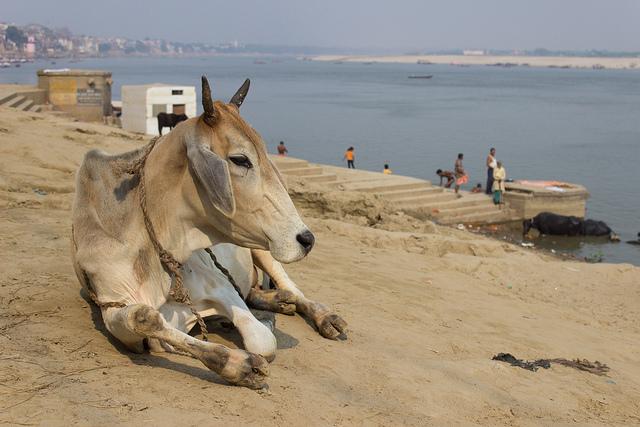Is this a farm?
Quick response, please. No. Is the area fenced in?
Give a very brief answer. No. Was this photograph taken in America?
Answer briefly. No. What color is the water?
Short answer required. Blue. How many horns?
Write a very short answer. 2. 